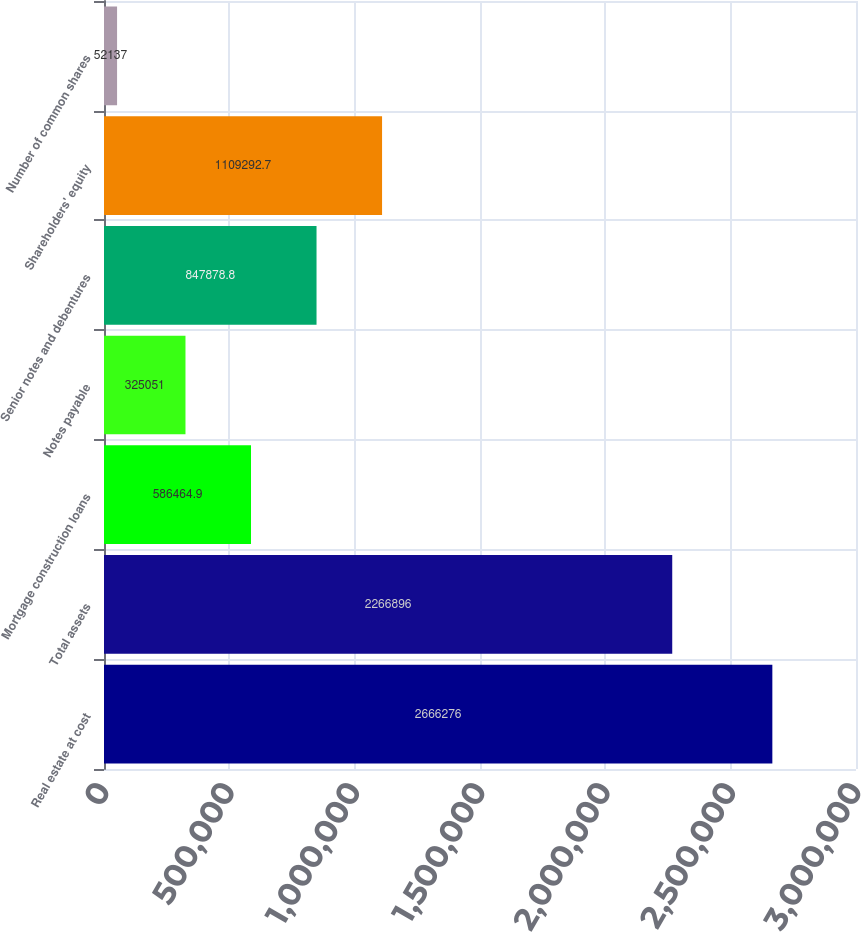Convert chart. <chart><loc_0><loc_0><loc_500><loc_500><bar_chart><fcel>Real estate at cost<fcel>Total assets<fcel>Mortgage construction loans<fcel>Notes payable<fcel>Senior notes and debentures<fcel>Shareholders' equity<fcel>Number of common shares<nl><fcel>2.66628e+06<fcel>2.2669e+06<fcel>586465<fcel>325051<fcel>847879<fcel>1.10929e+06<fcel>52137<nl></chart> 